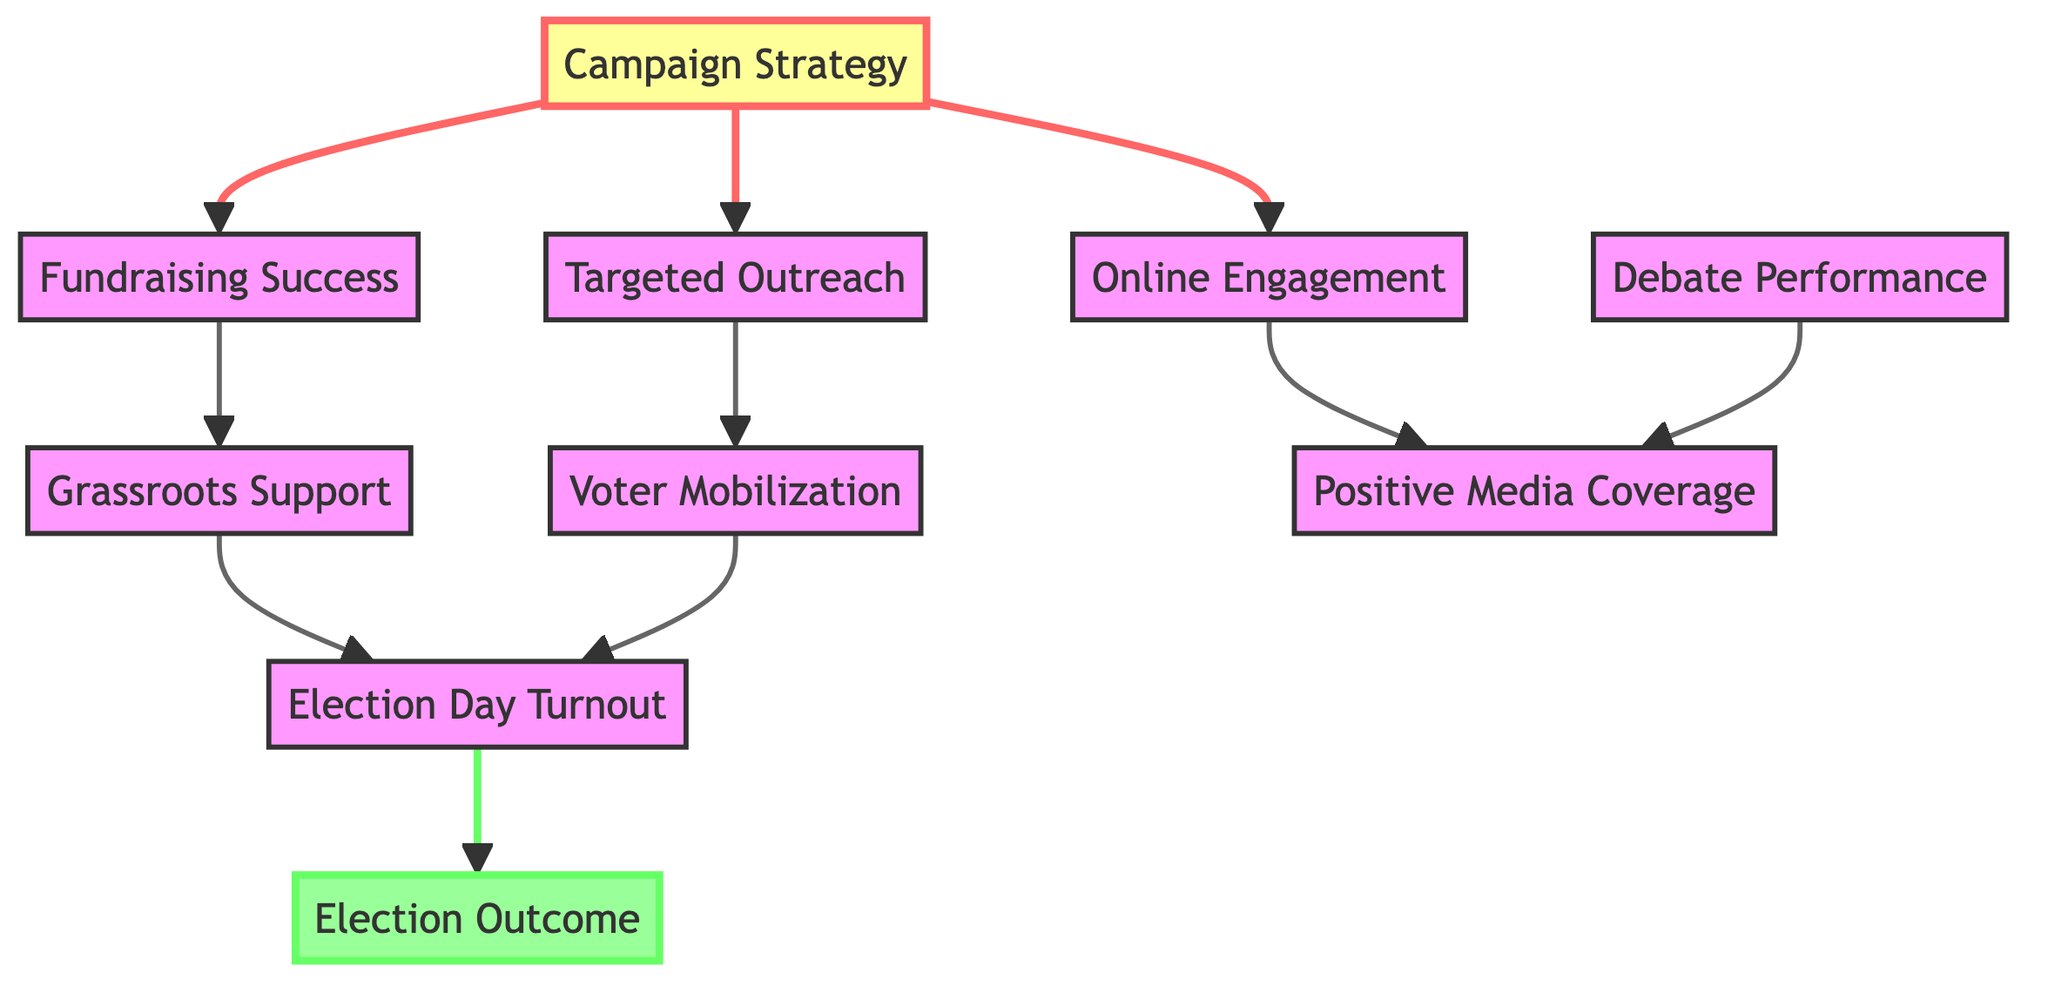What is the total number of nodes in the diagram? The diagram contains ten distinct nodes, which are: Campaign Strategy, Targeted Outreach, Online Engagement, Voter Mobilization, Debate Performance, Grassroots Support, Election Day Turnout, Positive Media Coverage, Fundraising Success, and Election Outcome.
Answer: 10 Which node leads to Election Day Turnout? The node Grassroots Support directly leads to Election Day Turnout, as per the directed edge shown in the diagram. Additionally, Voter Mobilization also leads to Election Day Turnout.
Answer: Grassroots Support, Voter Mobilization What is the relationship between Fundraising Success and Grassroots Support? Fundraising Success has a directed edge leading to Grassroots Support, indicating that successful fundraising efforts contribute to garnering grassroots support in the campaign strategy.
Answer: Directed How many directed edges are connecting Campaign Strategy to other nodes? There are three directed edges that connect Campaign Strategy to other nodes: one to Targeted Outreach, one to Online Engagement, and one to Fundraising Success.
Answer: 3 Which two nodes lead to Positive Media Coverage? Both Online Engagement and Debate Performance lead to Positive Media Coverage, as illustrated by the directed edges coming from these two nodes to Positive Media Coverage node.
Answer: Online Engagement, Debate Performance What is the final outcome represented in the diagram? The final outcome represented in the diagram is the Election Outcome, which is reached via the directed flow from Election Day Turnout.
Answer: Election Outcome If Grassroots Support is strong, what is the effect on Election Day Turnout? If Grassroots Support is strong, it leads to an increase in Election Day Turnout, as shown by the directed edge from Grassroots Support to Election Day Turnout.
Answer: Increase What is the starting point for the campaign strategies depicted in this diagram? The starting point for the campaign strategies depicted in this diagram is the Campaign Strategy node, which directs to several other strategies and activities.
Answer: Campaign Strategy 